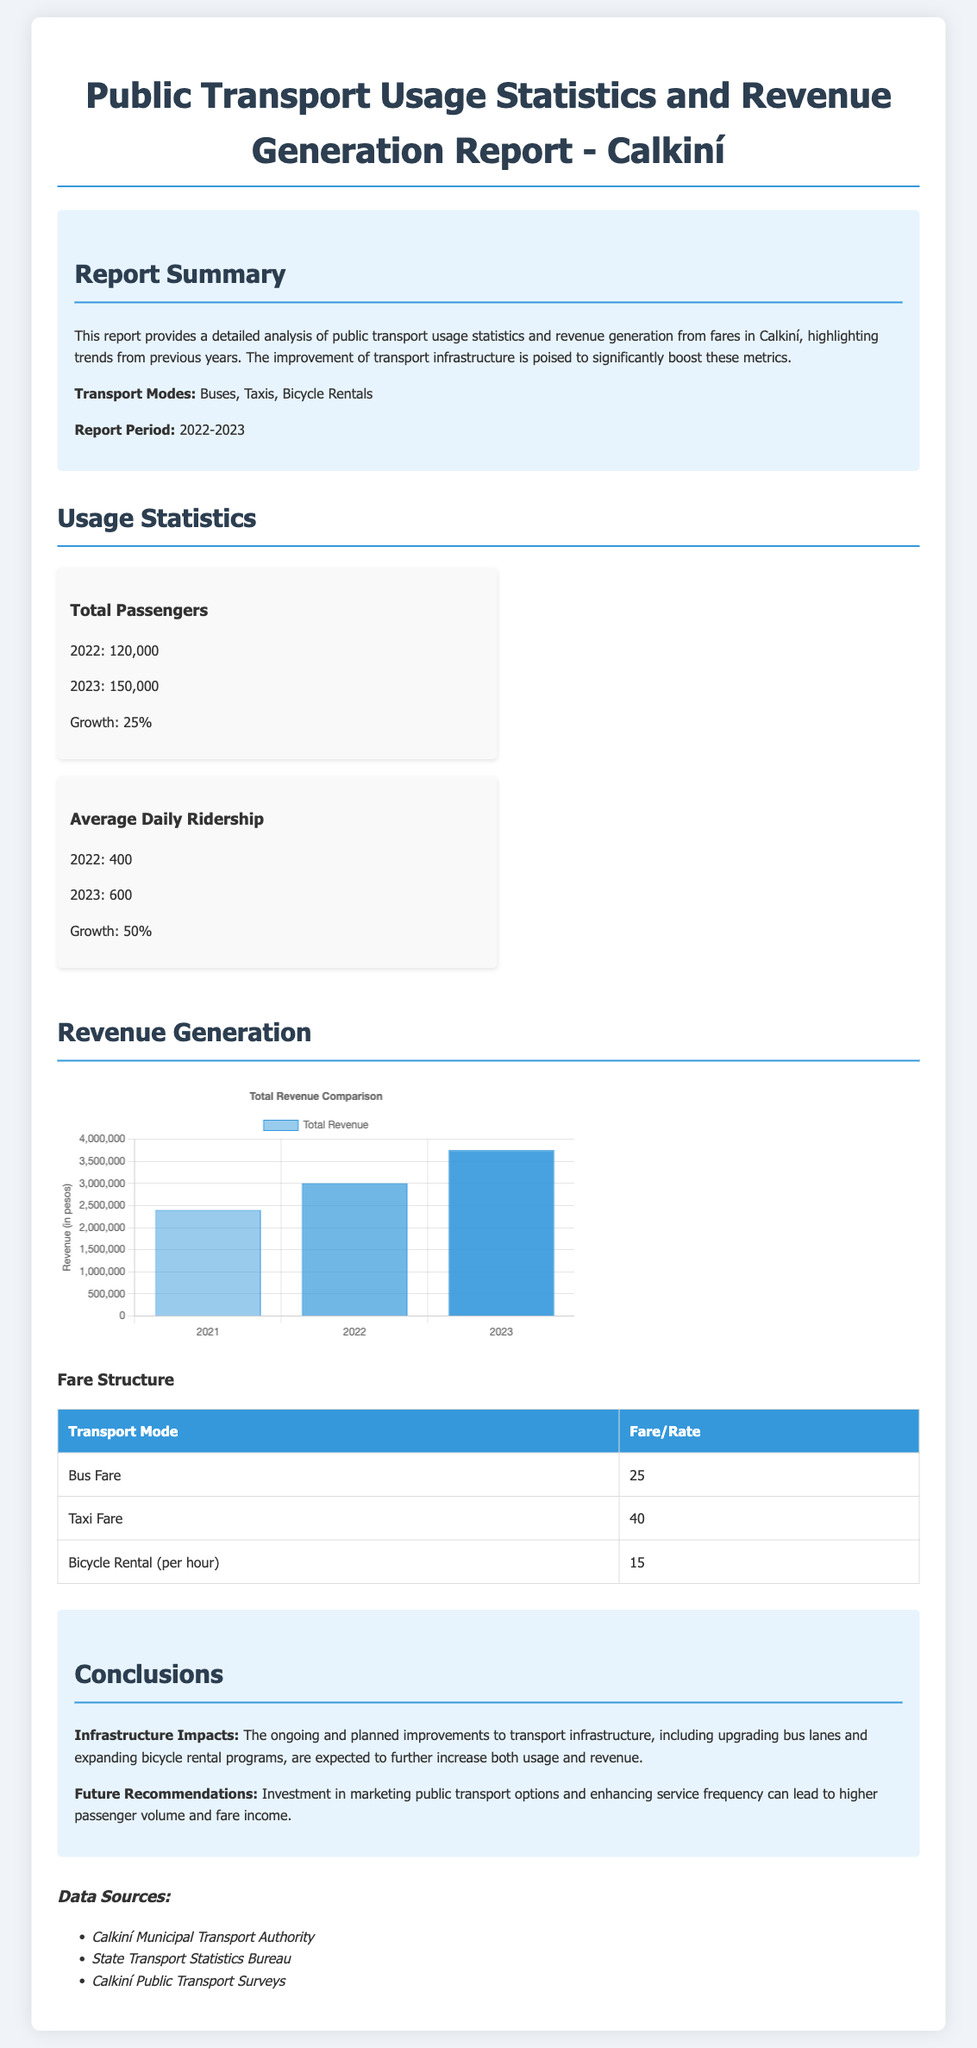What was the total number of passengers in 2023? The document states that the total number of passengers in 2023 was 150,000.
Answer: 150,000 What was the growth percentage of total passengers from 2022 to 2023? The report shows a growth percentage of 25% for total passengers from 2022 to 2023.
Answer: 25% How much revenue was generated in 2022? The revenue generated in 2022 is listed as 3,000,000 pesos in the chart.
Answer: 3,000,000 What is the average daily ridership in 2022? According to the stats, the average daily ridership in 2022 was 400.
Answer: 400 What transportation mode has the highest fare? The fare table indicates that Taxi Fare has the highest rate at 40 pesos.
Answer: Taxi Fare What is the expected impact of infrastructure improvements? The document states that the ongoing improvements to transport infrastructure are expected to further increase both usage and revenue.
Answer: Increase How many transport modes are mentioned in the report? The summary notes three transport modes: Buses, Taxis, and Bicycle Rentals.
Answer: Three Which year had the lowest total revenue? The chart indicates that 2021 had the lowest total revenue at 2,400,000 pesos.
Answer: 2021 What is the fare for bicycle rental per hour? The document states that Bicycle Rental fare is 15 pesos per hour.
Answer: 15 